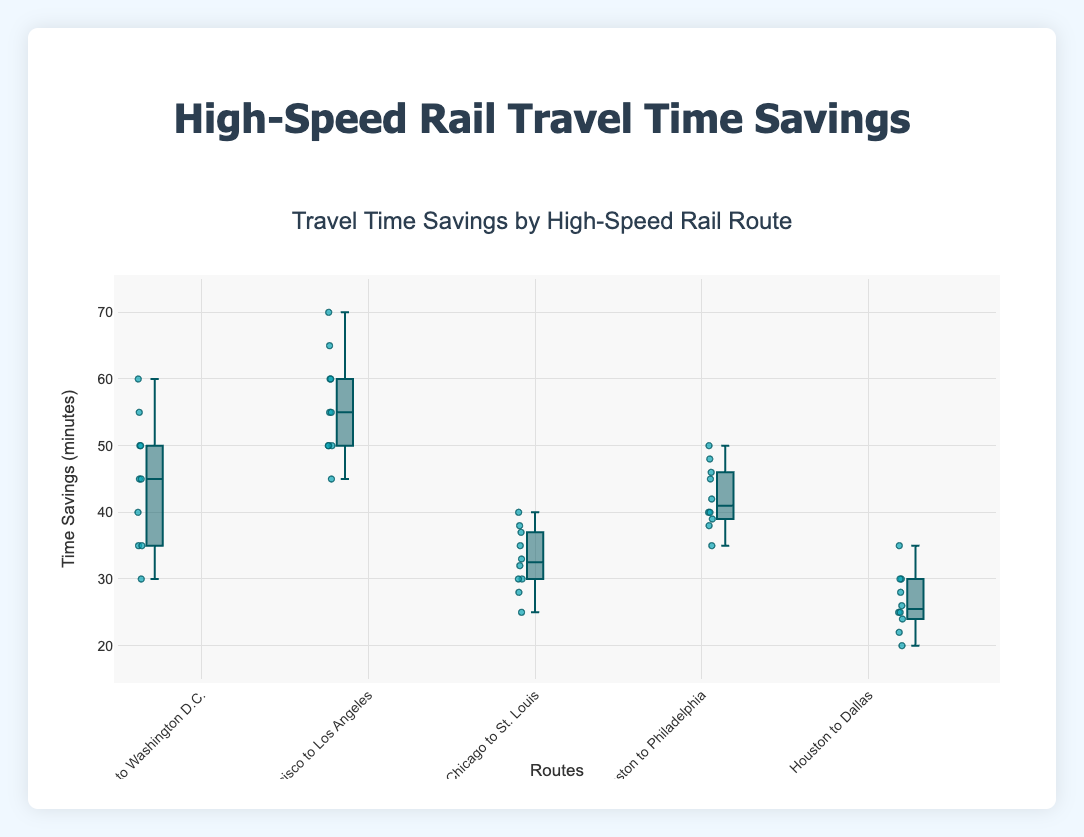What is the title of the figure? The title of the figure is displayed at the top.
Answer: Travel Time Savings by High-Speed Rail Route What does the y-axis represent? The label on the y-axis shows what is measured.
Answer: Time Savings (minutes) Which route shows the highest median travel time savings? The median is represented by the central line within each box; the route with the highest central line has the highest median travel time savings.
Answer: San Francisco to Los Angeles Which route has the most consistent travel time savings? Consistency is measured by the interquartile range (IQR), the distance between the upper and lower quartiles. The smallest IQR indicates the most consistency.
Answer: Chicago to St. Louis What is the range of travel time savings for the Boston to Philadelphia route? Determine the minimum and maximum values within the points of the Boston to Philadelphia box plot.
Answer: 35 to 50 minutes Which route shows the widest spread in travel time savings? The spread can be evaluated by looking at the total range (difference between the maximum and minimum values) of the box plot for each route.
Answer: San Francisco to Los Angeles How does the travel time savings for Houston to Dallas compare to New York to Washington D.C.? Compare the respective ranges, medians, and IQRs of the two routes to determine how they differ.
Answer: Houston to Dallas has lower median and smaller range Between which routes is the median travel time savings difference the greatest? Compare the central line values (medians) of each box plot and identify the two routes with the largest difference.
Answer: San Francisco to Los Angeles and Houston to Dallas What is the interquartile range (IQR) for the travel time savings of the New York to Washington D.C. route? The IQR is the difference between the third quartile (Q3) and the first quartile (Q1), represented by the upper and lower edges of the box.
Answer: 45 - 35 = 10 minutes Which route has the most outliers in travel time savings? Outliers are shown as individual points outside the box plots; the route with the most such points has the most outliers.
Answer: New York to Washington D.C 